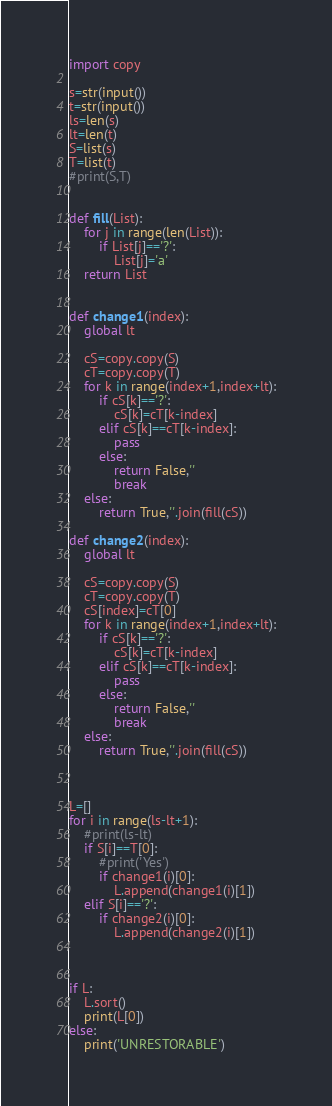<code> <loc_0><loc_0><loc_500><loc_500><_Python_>import copy

s=str(input())
t=str(input())
ls=len(s)
lt=len(t)
S=list(s)
T=list(t)
#print(S,T)


def fill(List):
    for j in range(len(List)):
        if List[j]=='?':
            List[j]='a'
    return List


def change1(index):
    global lt

    cS=copy.copy(S)
    cT=copy.copy(T)
    for k in range(index+1,index+lt):
        if cS[k]=='?':
            cS[k]=cT[k-index]
        elif cS[k]==cT[k-index]:
            pass
        else:
            return False,''
            break
    else:
        return True,''.join(fill(cS))

def change2(index):
    global lt

    cS=copy.copy(S)
    cT=copy.copy(T)
    cS[index]=cT[0]
    for k in range(index+1,index+lt):
        if cS[k]=='?':
            cS[k]=cT[k-index]
        elif cS[k]==cT[k-index]:
            pass
        else:
            return False,''
            break
    else:
        return True,''.join(fill(cS))



L=[]
for i in range(ls-lt+1):
    #print(ls-lt)
    if S[i]==T[0]:
        #print('Yes')
        if change1(i)[0]:
            L.append(change1(i)[1])
    elif S[i]=='?':
        if change2(i)[0]:
            L.append(change2(i)[1])
    


if L:
    L.sort()
    print(L[0])
else:
    print('UNRESTORABLE')</code> 